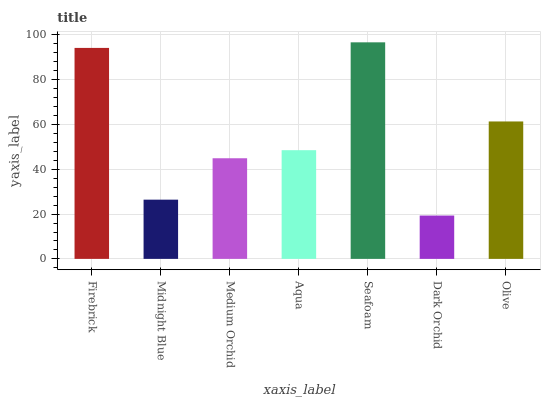Is Dark Orchid the minimum?
Answer yes or no. Yes. Is Seafoam the maximum?
Answer yes or no. Yes. Is Midnight Blue the minimum?
Answer yes or no. No. Is Midnight Blue the maximum?
Answer yes or no. No. Is Firebrick greater than Midnight Blue?
Answer yes or no. Yes. Is Midnight Blue less than Firebrick?
Answer yes or no. Yes. Is Midnight Blue greater than Firebrick?
Answer yes or no. No. Is Firebrick less than Midnight Blue?
Answer yes or no. No. Is Aqua the high median?
Answer yes or no. Yes. Is Aqua the low median?
Answer yes or no. Yes. Is Dark Orchid the high median?
Answer yes or no. No. Is Dark Orchid the low median?
Answer yes or no. No. 